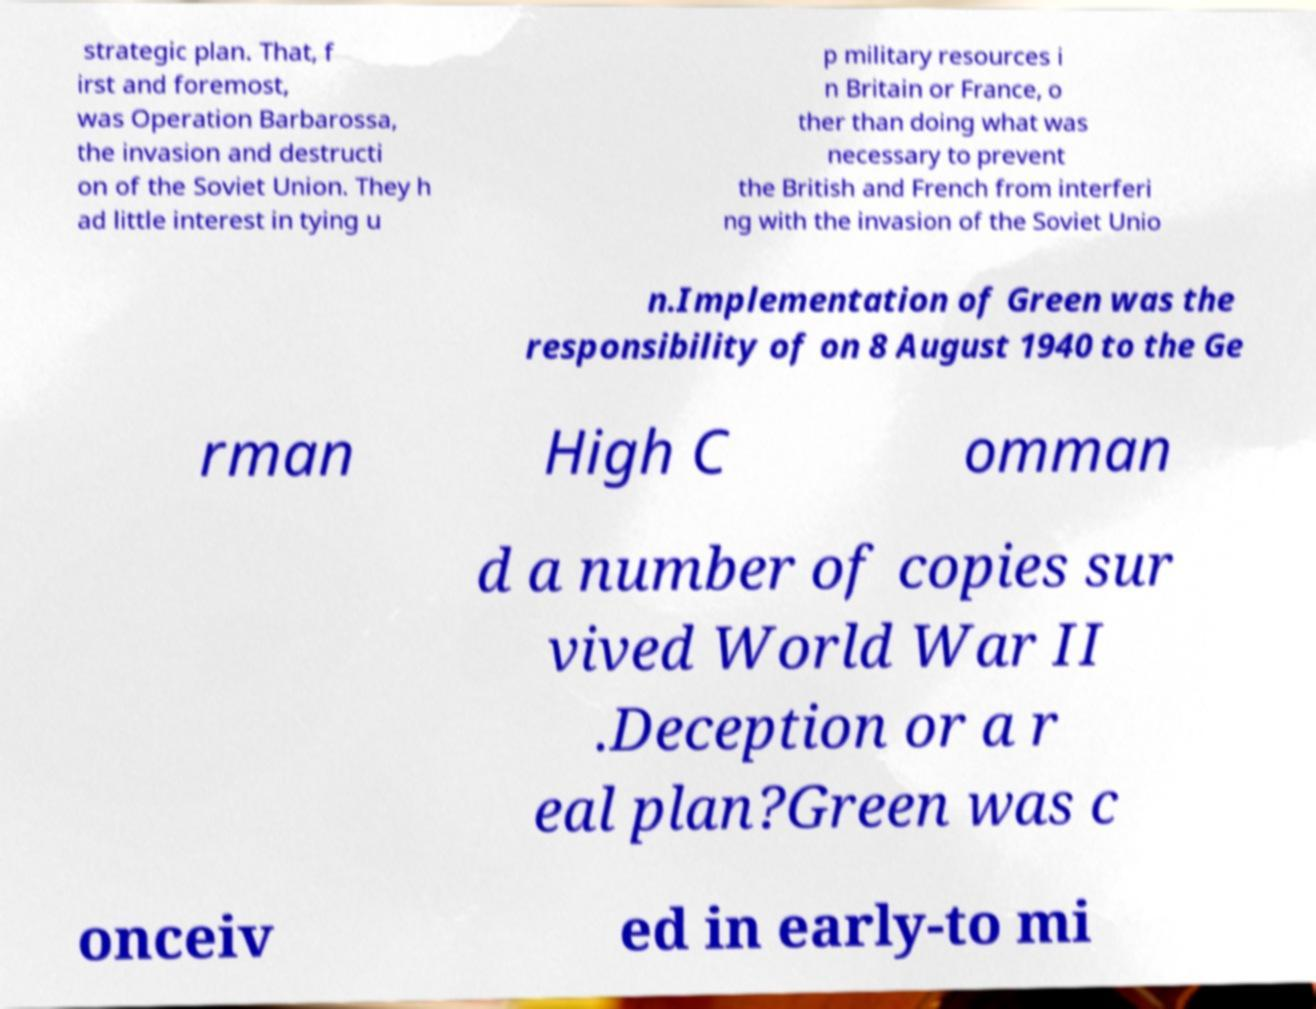I need the written content from this picture converted into text. Can you do that? strategic plan. That, f irst and foremost, was Operation Barbarossa, the invasion and destructi on of the Soviet Union. They h ad little interest in tying u p military resources i n Britain or France, o ther than doing what was necessary to prevent the British and French from interferi ng with the invasion of the Soviet Unio n.Implementation of Green was the responsibility of on 8 August 1940 to the Ge rman High C omman d a number of copies sur vived World War II .Deception or a r eal plan?Green was c onceiv ed in early-to mi 